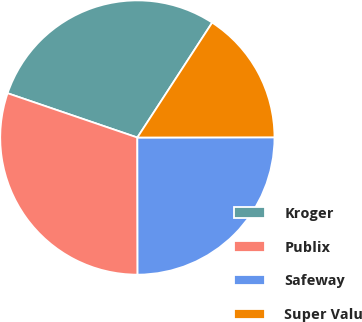<chart> <loc_0><loc_0><loc_500><loc_500><pie_chart><fcel>Kroger<fcel>Publix<fcel>Safeway<fcel>Super Valu<nl><fcel>28.95%<fcel>30.26%<fcel>25.0%<fcel>15.79%<nl></chart> 